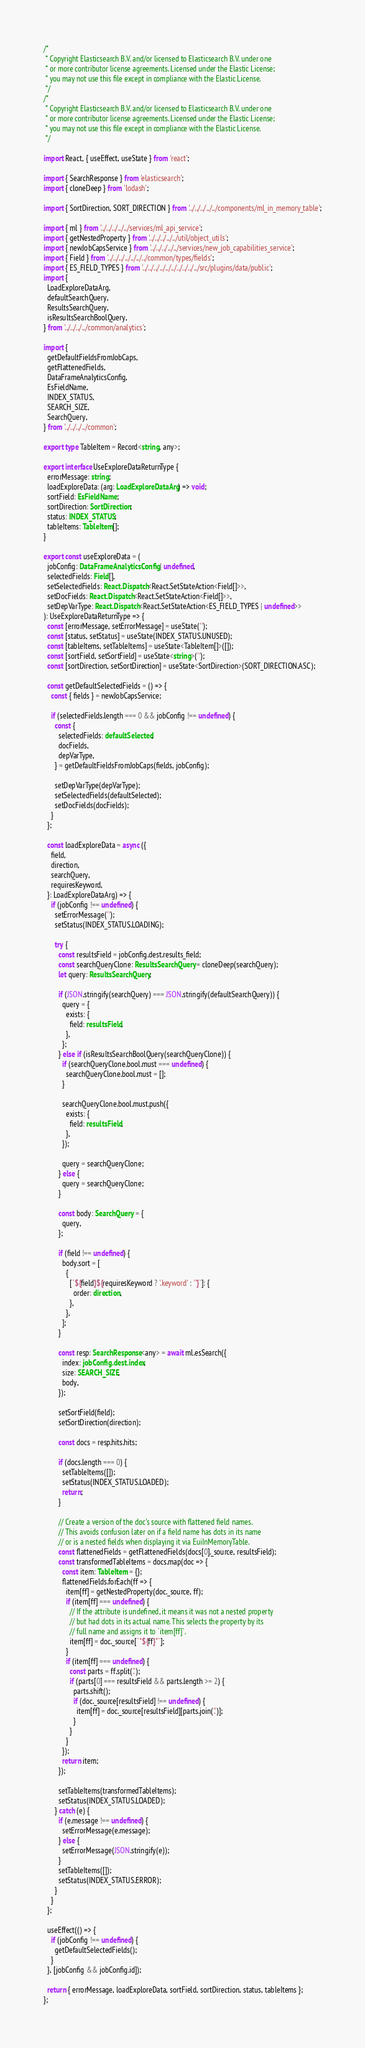Convert code to text. <code><loc_0><loc_0><loc_500><loc_500><_TypeScript_>/*
 * Copyright Elasticsearch B.V. and/or licensed to Elasticsearch B.V. under one
 * or more contributor license agreements. Licensed under the Elastic License;
 * you may not use this file except in compliance with the Elastic License.
 */
/*
 * Copyright Elasticsearch B.V. and/or licensed to Elasticsearch B.V. under one
 * or more contributor license agreements. Licensed under the Elastic License;
 * you may not use this file except in compliance with the Elastic License.
 */

import React, { useEffect, useState } from 'react';

import { SearchResponse } from 'elasticsearch';
import { cloneDeep } from 'lodash';

import { SortDirection, SORT_DIRECTION } from '../../../../../components/ml_in_memory_table';

import { ml } from '../../../../../services/ml_api_service';
import { getNestedProperty } from '../../../../../util/object_utils';
import { newJobCapsService } from '../../../../../services/new_job_capabilities_service';
import { Field } from '../../../../../../../common/types/fields';
import { ES_FIELD_TYPES } from '../../../../../../../../../../src/plugins/data/public';
import {
  LoadExploreDataArg,
  defaultSearchQuery,
  ResultsSearchQuery,
  isResultsSearchBoolQuery,
} from '../../../../common/analytics';

import {
  getDefaultFieldsFromJobCaps,
  getFlattenedFields,
  DataFrameAnalyticsConfig,
  EsFieldName,
  INDEX_STATUS,
  SEARCH_SIZE,
  SearchQuery,
} from '../../../../common';

export type TableItem = Record<string, any>;

export interface UseExploreDataReturnType {
  errorMessage: string;
  loadExploreData: (arg: LoadExploreDataArg) => void;
  sortField: EsFieldName;
  sortDirection: SortDirection;
  status: INDEX_STATUS;
  tableItems: TableItem[];
}

export const useExploreData = (
  jobConfig: DataFrameAnalyticsConfig | undefined,
  selectedFields: Field[],
  setSelectedFields: React.Dispatch<React.SetStateAction<Field[]>>,
  setDocFields: React.Dispatch<React.SetStateAction<Field[]>>,
  setDepVarType: React.Dispatch<React.SetStateAction<ES_FIELD_TYPES | undefined>>
): UseExploreDataReturnType => {
  const [errorMessage, setErrorMessage] = useState('');
  const [status, setStatus] = useState(INDEX_STATUS.UNUSED);
  const [tableItems, setTableItems] = useState<TableItem[]>([]);
  const [sortField, setSortField] = useState<string>('');
  const [sortDirection, setSortDirection] = useState<SortDirection>(SORT_DIRECTION.ASC);

  const getDefaultSelectedFields = () => {
    const { fields } = newJobCapsService;

    if (selectedFields.length === 0 && jobConfig !== undefined) {
      const {
        selectedFields: defaultSelected,
        docFields,
        depVarType,
      } = getDefaultFieldsFromJobCaps(fields, jobConfig);

      setDepVarType(depVarType);
      setSelectedFields(defaultSelected);
      setDocFields(docFields);
    }
  };

  const loadExploreData = async ({
    field,
    direction,
    searchQuery,
    requiresKeyword,
  }: LoadExploreDataArg) => {
    if (jobConfig !== undefined) {
      setErrorMessage('');
      setStatus(INDEX_STATUS.LOADING);

      try {
        const resultsField = jobConfig.dest.results_field;
        const searchQueryClone: ResultsSearchQuery = cloneDeep(searchQuery);
        let query: ResultsSearchQuery;

        if (JSON.stringify(searchQuery) === JSON.stringify(defaultSearchQuery)) {
          query = {
            exists: {
              field: resultsField,
            },
          };
        } else if (isResultsSearchBoolQuery(searchQueryClone)) {
          if (searchQueryClone.bool.must === undefined) {
            searchQueryClone.bool.must = [];
          }

          searchQueryClone.bool.must.push({
            exists: {
              field: resultsField,
            },
          });

          query = searchQueryClone;
        } else {
          query = searchQueryClone;
        }

        const body: SearchQuery = {
          query,
        };

        if (field !== undefined) {
          body.sort = [
            {
              [`${field}${requiresKeyword ? '.keyword' : ''}`]: {
                order: direction,
              },
            },
          ];
        }

        const resp: SearchResponse<any> = await ml.esSearch({
          index: jobConfig.dest.index,
          size: SEARCH_SIZE,
          body,
        });

        setSortField(field);
        setSortDirection(direction);

        const docs = resp.hits.hits;

        if (docs.length === 0) {
          setTableItems([]);
          setStatus(INDEX_STATUS.LOADED);
          return;
        }

        // Create a version of the doc's source with flattened field names.
        // This avoids confusion later on if a field name has dots in its name
        // or is a nested fields when displaying it via EuiInMemoryTable.
        const flattenedFields = getFlattenedFields(docs[0]._source, resultsField);
        const transformedTableItems = docs.map(doc => {
          const item: TableItem = {};
          flattenedFields.forEach(ff => {
            item[ff] = getNestedProperty(doc._source, ff);
            if (item[ff] === undefined) {
              // If the attribute is undefined, it means it was not a nested property
              // but had dots in its actual name. This selects the property by its
              // full name and assigns it to `item[ff]`.
              item[ff] = doc._source[`"${ff}"`];
            }
            if (item[ff] === undefined) {
              const parts = ff.split('.');
              if (parts[0] === resultsField && parts.length >= 2) {
                parts.shift();
                if (doc._source[resultsField] !== undefined) {
                  item[ff] = doc._source[resultsField][parts.join('.')];
                }
              }
            }
          });
          return item;
        });

        setTableItems(transformedTableItems);
        setStatus(INDEX_STATUS.LOADED);
      } catch (e) {
        if (e.message !== undefined) {
          setErrorMessage(e.message);
        } else {
          setErrorMessage(JSON.stringify(e));
        }
        setTableItems([]);
        setStatus(INDEX_STATUS.ERROR);
      }
    }
  };

  useEffect(() => {
    if (jobConfig !== undefined) {
      getDefaultSelectedFields();
    }
  }, [jobConfig && jobConfig.id]);

  return { errorMessage, loadExploreData, sortField, sortDirection, status, tableItems };
};
</code> 